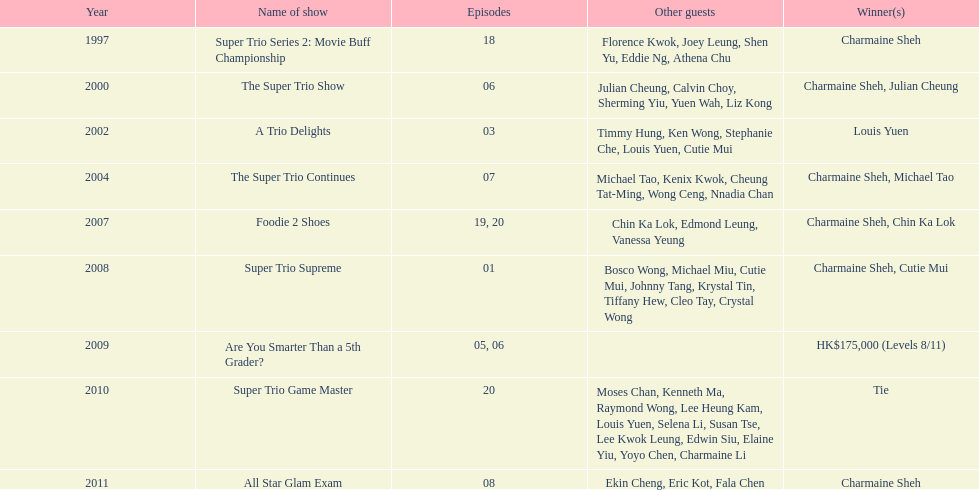How many times has charmaine sheh emerged as a winner on a variety show? 6. 